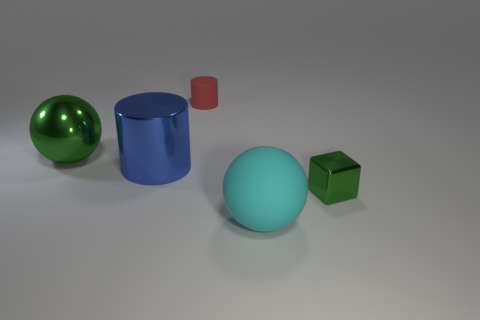What number of other things are the same shape as the blue shiny thing?
Offer a very short reply. 1. What color is the object that is behind the large blue metal object and in front of the tiny red cylinder?
Make the answer very short. Green. What color is the large cylinder?
Your answer should be compact. Blue. Is the green sphere made of the same material as the green thing to the right of the blue metal cylinder?
Keep it short and to the point. Yes. There is another big thing that is made of the same material as the blue thing; what is its shape?
Provide a short and direct response. Sphere. What color is the cylinder that is the same size as the green metallic block?
Your answer should be compact. Red. Is the size of the green thing right of the cyan object the same as the large blue object?
Give a very brief answer. No. Do the small block and the small cylinder have the same color?
Provide a short and direct response. No. What number of yellow cylinders are there?
Your response must be concise. 0. How many cylinders are either large green metal objects or tiny red matte things?
Your answer should be compact. 1. 